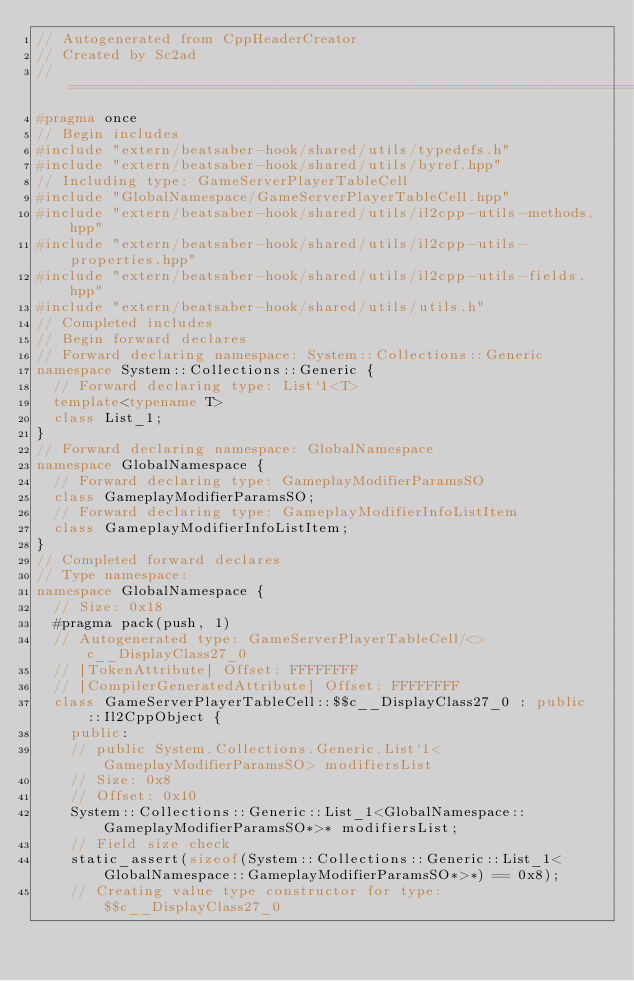<code> <loc_0><loc_0><loc_500><loc_500><_C++_>// Autogenerated from CppHeaderCreator
// Created by Sc2ad
// =========================================================================
#pragma once
// Begin includes
#include "extern/beatsaber-hook/shared/utils/typedefs.h"
#include "extern/beatsaber-hook/shared/utils/byref.hpp"
// Including type: GameServerPlayerTableCell
#include "GlobalNamespace/GameServerPlayerTableCell.hpp"
#include "extern/beatsaber-hook/shared/utils/il2cpp-utils-methods.hpp"
#include "extern/beatsaber-hook/shared/utils/il2cpp-utils-properties.hpp"
#include "extern/beatsaber-hook/shared/utils/il2cpp-utils-fields.hpp"
#include "extern/beatsaber-hook/shared/utils/utils.h"
// Completed includes
// Begin forward declares
// Forward declaring namespace: System::Collections::Generic
namespace System::Collections::Generic {
  // Forward declaring type: List`1<T>
  template<typename T>
  class List_1;
}
// Forward declaring namespace: GlobalNamespace
namespace GlobalNamespace {
  // Forward declaring type: GameplayModifierParamsSO
  class GameplayModifierParamsSO;
  // Forward declaring type: GameplayModifierInfoListItem
  class GameplayModifierInfoListItem;
}
// Completed forward declares
// Type namespace: 
namespace GlobalNamespace {
  // Size: 0x18
  #pragma pack(push, 1)
  // Autogenerated type: GameServerPlayerTableCell/<>c__DisplayClass27_0
  // [TokenAttribute] Offset: FFFFFFFF
  // [CompilerGeneratedAttribute] Offset: FFFFFFFF
  class GameServerPlayerTableCell::$$c__DisplayClass27_0 : public ::Il2CppObject {
    public:
    // public System.Collections.Generic.List`1<GameplayModifierParamsSO> modifiersList
    // Size: 0x8
    // Offset: 0x10
    System::Collections::Generic::List_1<GlobalNamespace::GameplayModifierParamsSO*>* modifiersList;
    // Field size check
    static_assert(sizeof(System::Collections::Generic::List_1<GlobalNamespace::GameplayModifierParamsSO*>*) == 0x8);
    // Creating value type constructor for type: $$c__DisplayClass27_0</code> 